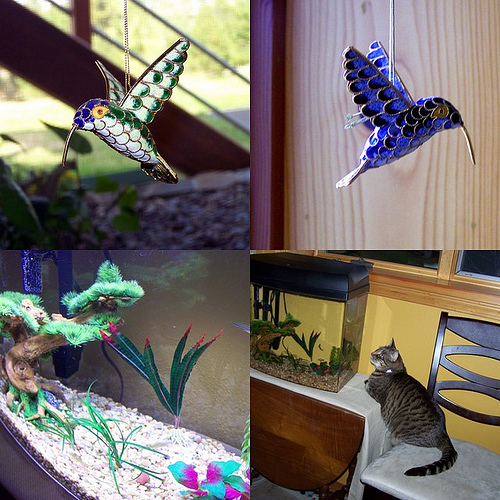Reflecting on the top images, can you describe the artistic characteristics of the stained glass birds? The stained glass birds exhibit a kaleidoscope of colors that mimic the natural iridescence of hummingbird feathers. The artistry lies in the intricate cutting of each glass piece and its assembly to form a cohesive, life-like figure. Notice the thoughtful arrangement of colors and shapes that suggest the delicate motion of the birds in flight, an interplay of art and light. 